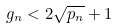<formula> <loc_0><loc_0><loc_500><loc_500>g _ { n } < 2 \sqrt { p _ { n } } + 1</formula> 